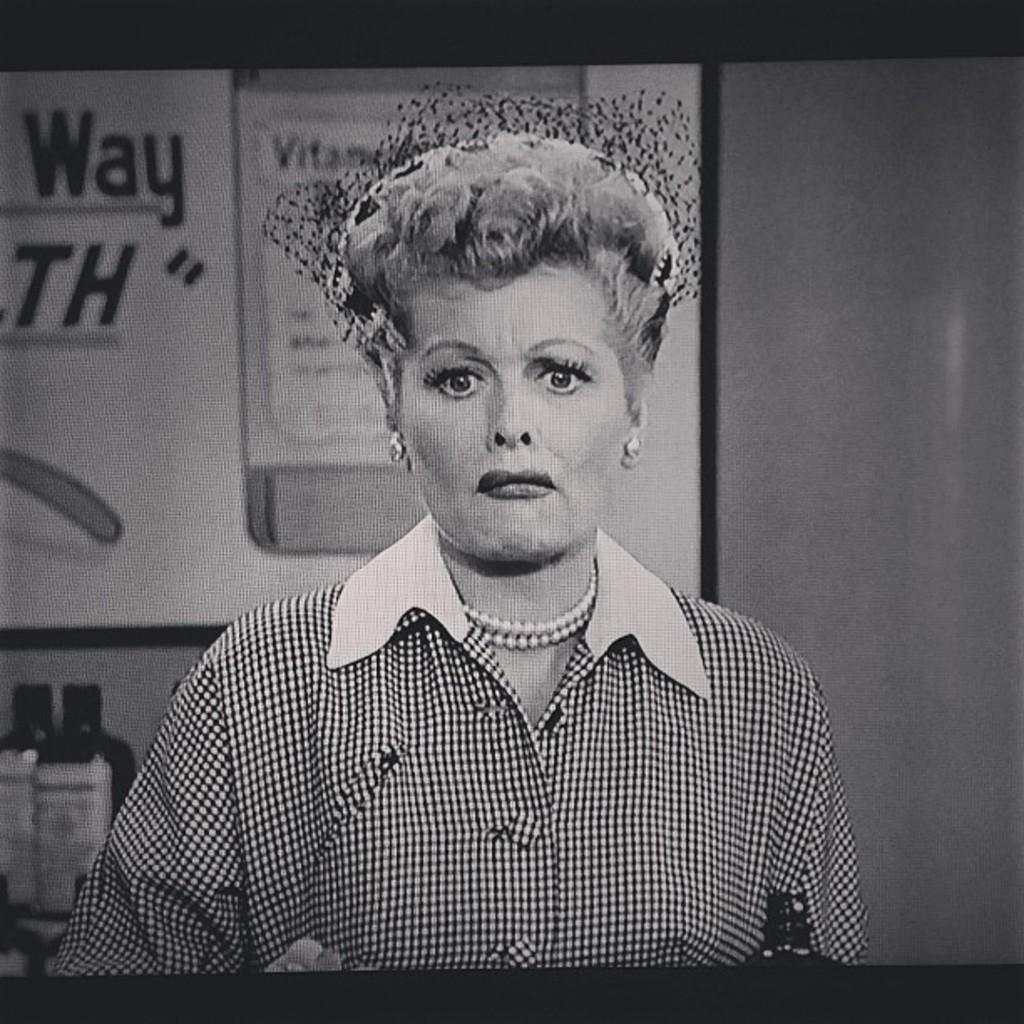Can you describe this image briefly? In the picture I can see a woman in the middle of the image. She is wearing a shirt and I can see the pearl necklace on her neck. I can see the glass bottles on the bottom left side of the picture. 